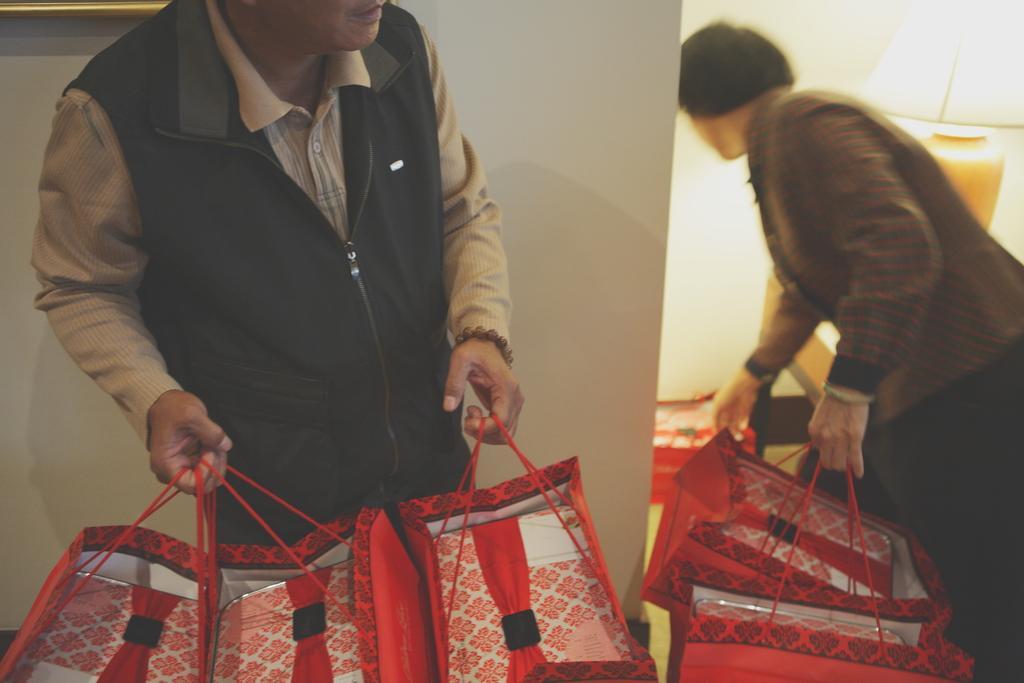Please provide a concise description of this image. In this image we can see the inner view of a room and we can see two persons holding some bags in their hands and we can see a lamp on the right side of the image. 